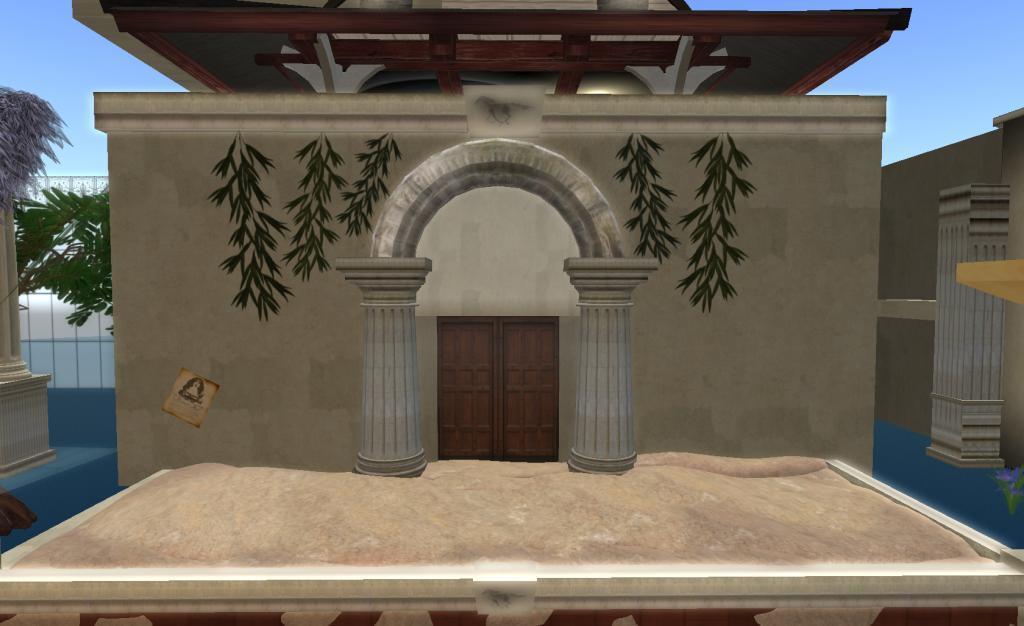In one or two sentences, can you explain what this image depicts? In this image I can see the animation picture. I can see few buildings, trees, fencing and the sky is in blue and white color. 